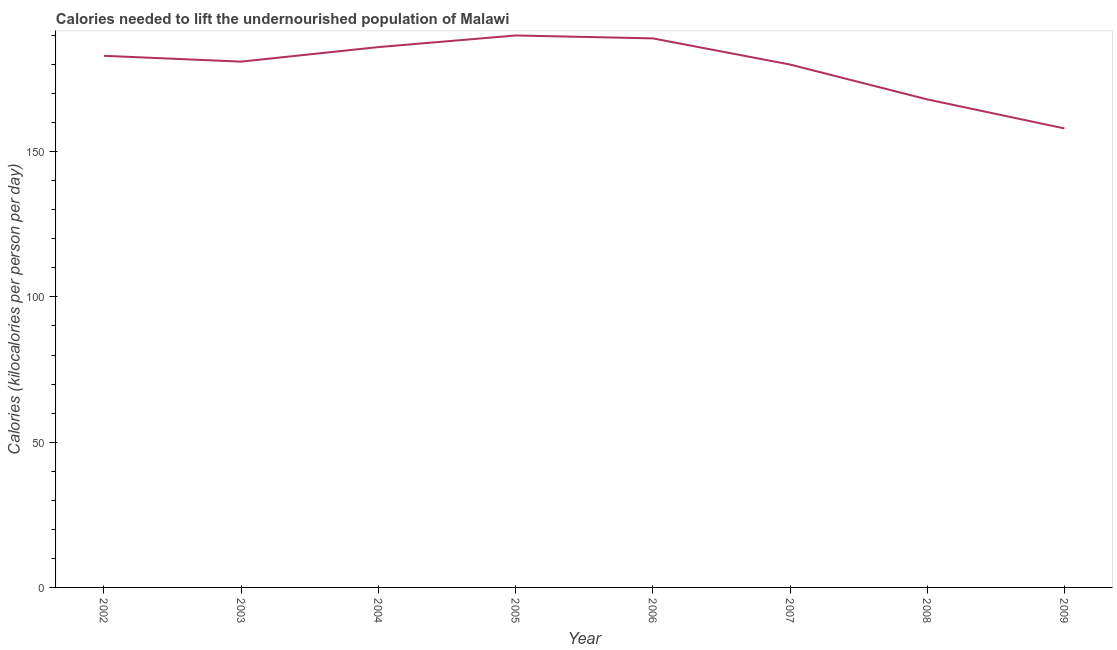What is the depth of food deficit in 2005?
Your response must be concise. 190. Across all years, what is the maximum depth of food deficit?
Make the answer very short. 190. Across all years, what is the minimum depth of food deficit?
Your answer should be compact. 158. In which year was the depth of food deficit maximum?
Your answer should be very brief. 2005. What is the sum of the depth of food deficit?
Your answer should be compact. 1435. What is the difference between the depth of food deficit in 2002 and 2005?
Your response must be concise. -7. What is the average depth of food deficit per year?
Keep it short and to the point. 179.38. What is the median depth of food deficit?
Provide a short and direct response. 182. In how many years, is the depth of food deficit greater than 30 kilocalories?
Provide a succinct answer. 8. What is the ratio of the depth of food deficit in 2003 to that in 2009?
Provide a short and direct response. 1.15. Is the sum of the depth of food deficit in 2002 and 2005 greater than the maximum depth of food deficit across all years?
Offer a terse response. Yes. What is the difference between the highest and the lowest depth of food deficit?
Keep it short and to the point. 32. In how many years, is the depth of food deficit greater than the average depth of food deficit taken over all years?
Ensure brevity in your answer.  6. How many years are there in the graph?
Your answer should be very brief. 8. What is the difference between two consecutive major ticks on the Y-axis?
Provide a succinct answer. 50. Are the values on the major ticks of Y-axis written in scientific E-notation?
Provide a short and direct response. No. Does the graph contain grids?
Offer a very short reply. No. What is the title of the graph?
Make the answer very short. Calories needed to lift the undernourished population of Malawi. What is the label or title of the Y-axis?
Your answer should be compact. Calories (kilocalories per person per day). What is the Calories (kilocalories per person per day) of 2002?
Give a very brief answer. 183. What is the Calories (kilocalories per person per day) of 2003?
Your answer should be very brief. 181. What is the Calories (kilocalories per person per day) in 2004?
Make the answer very short. 186. What is the Calories (kilocalories per person per day) in 2005?
Provide a short and direct response. 190. What is the Calories (kilocalories per person per day) of 2006?
Ensure brevity in your answer.  189. What is the Calories (kilocalories per person per day) in 2007?
Give a very brief answer. 180. What is the Calories (kilocalories per person per day) of 2008?
Ensure brevity in your answer.  168. What is the Calories (kilocalories per person per day) of 2009?
Your answer should be very brief. 158. What is the difference between the Calories (kilocalories per person per day) in 2002 and 2007?
Your answer should be very brief. 3. What is the difference between the Calories (kilocalories per person per day) in 2002 and 2008?
Ensure brevity in your answer.  15. What is the difference between the Calories (kilocalories per person per day) in 2003 and 2005?
Offer a terse response. -9. What is the difference between the Calories (kilocalories per person per day) in 2003 and 2006?
Keep it short and to the point. -8. What is the difference between the Calories (kilocalories per person per day) in 2003 and 2007?
Keep it short and to the point. 1. What is the difference between the Calories (kilocalories per person per day) in 2003 and 2009?
Your answer should be compact. 23. What is the difference between the Calories (kilocalories per person per day) in 2004 and 2007?
Offer a very short reply. 6. What is the difference between the Calories (kilocalories per person per day) in 2005 and 2006?
Make the answer very short. 1. What is the difference between the Calories (kilocalories per person per day) in 2005 and 2007?
Your response must be concise. 10. What is the difference between the Calories (kilocalories per person per day) in 2006 and 2007?
Keep it short and to the point. 9. What is the difference between the Calories (kilocalories per person per day) in 2006 and 2008?
Keep it short and to the point. 21. What is the difference between the Calories (kilocalories per person per day) in 2008 and 2009?
Make the answer very short. 10. What is the ratio of the Calories (kilocalories per person per day) in 2002 to that in 2008?
Offer a terse response. 1.09. What is the ratio of the Calories (kilocalories per person per day) in 2002 to that in 2009?
Provide a succinct answer. 1.16. What is the ratio of the Calories (kilocalories per person per day) in 2003 to that in 2005?
Offer a terse response. 0.95. What is the ratio of the Calories (kilocalories per person per day) in 2003 to that in 2006?
Your answer should be compact. 0.96. What is the ratio of the Calories (kilocalories per person per day) in 2003 to that in 2008?
Keep it short and to the point. 1.08. What is the ratio of the Calories (kilocalories per person per day) in 2003 to that in 2009?
Offer a terse response. 1.15. What is the ratio of the Calories (kilocalories per person per day) in 2004 to that in 2005?
Provide a short and direct response. 0.98. What is the ratio of the Calories (kilocalories per person per day) in 2004 to that in 2006?
Your answer should be compact. 0.98. What is the ratio of the Calories (kilocalories per person per day) in 2004 to that in 2007?
Provide a succinct answer. 1.03. What is the ratio of the Calories (kilocalories per person per day) in 2004 to that in 2008?
Provide a succinct answer. 1.11. What is the ratio of the Calories (kilocalories per person per day) in 2004 to that in 2009?
Offer a very short reply. 1.18. What is the ratio of the Calories (kilocalories per person per day) in 2005 to that in 2007?
Your answer should be compact. 1.06. What is the ratio of the Calories (kilocalories per person per day) in 2005 to that in 2008?
Keep it short and to the point. 1.13. What is the ratio of the Calories (kilocalories per person per day) in 2005 to that in 2009?
Ensure brevity in your answer.  1.2. What is the ratio of the Calories (kilocalories per person per day) in 2006 to that in 2007?
Keep it short and to the point. 1.05. What is the ratio of the Calories (kilocalories per person per day) in 2006 to that in 2009?
Provide a succinct answer. 1.2. What is the ratio of the Calories (kilocalories per person per day) in 2007 to that in 2008?
Give a very brief answer. 1.07. What is the ratio of the Calories (kilocalories per person per day) in 2007 to that in 2009?
Offer a very short reply. 1.14. What is the ratio of the Calories (kilocalories per person per day) in 2008 to that in 2009?
Keep it short and to the point. 1.06. 